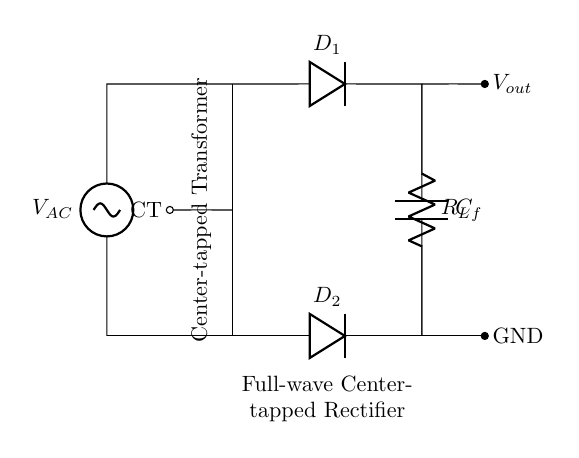What is the type of transformer used in the circuit? The circuit uses a center-tapped transformer, indicated by the labeling "CT" on the left side. This labeling signifies that the transformer has a central tap which allows for full-wave rectification.
Answer: center-tapped transformer How many diodes are present in this rectifier circuit? There are two diodes in the circuit, referred to as D1 and D2, as shown in the diagram. They are essential for the full-wave rectification process.
Answer: 2 What is the function of the capacitor in the circuit? The capacitor, labeled C_f, serves to smooth out the output voltage by filtering the ripples from the rectified signal, providing a more stable DC output.
Answer: smoothing What is the role of the load resistance in this circuit? The load resistance, labeled R_L, represents the output load where the power is delivered. It is critical as it defines the current flow and the voltage drop in the circuit.
Answer: output load What is the output voltage configuration of this rectifier? The full-wave center-tapped configuration produces a DC output voltage that is approximately double the peak voltage of the transformer secondary winding. This is because both halves of the AC waveform are utilized.
Answer: double the peak voltage Which component determines the direction of current flow in the circuit? The diodes (D1 and D2) are responsible for allowing current to flow in one direction only, thereby converting the alternating current (AC) into direct current (DC).
Answer: diodes 